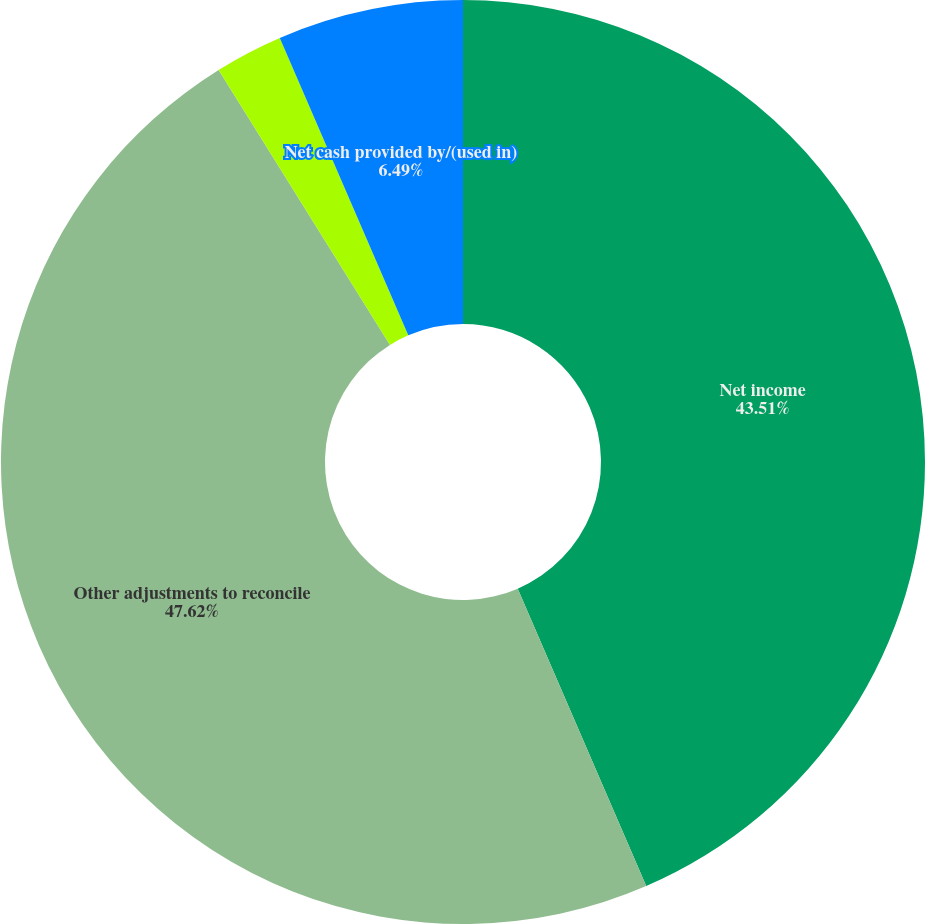Convert chart. <chart><loc_0><loc_0><loc_500><loc_500><pie_chart><fcel>Net income<fcel>Other adjustments to reconcile<fcel>Net cash (used in)/provided by<fcel>Net cash provided by/(used in)<nl><fcel>43.51%<fcel>47.62%<fcel>2.38%<fcel>6.49%<nl></chart> 